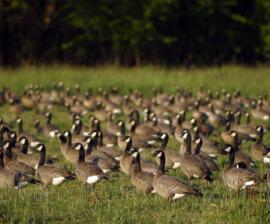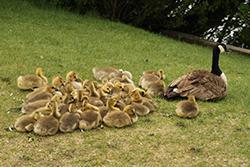The first image is the image on the left, the second image is the image on the right. Evaluate the accuracy of this statement regarding the images: "Exactly two Canada geese are in or near a body of water.". Is it true? Answer yes or no. No. The first image is the image on the left, the second image is the image on the right. Examine the images to the left and right. Is the description "One of the images shows exactly two geese." accurate? Answer yes or no. No. 